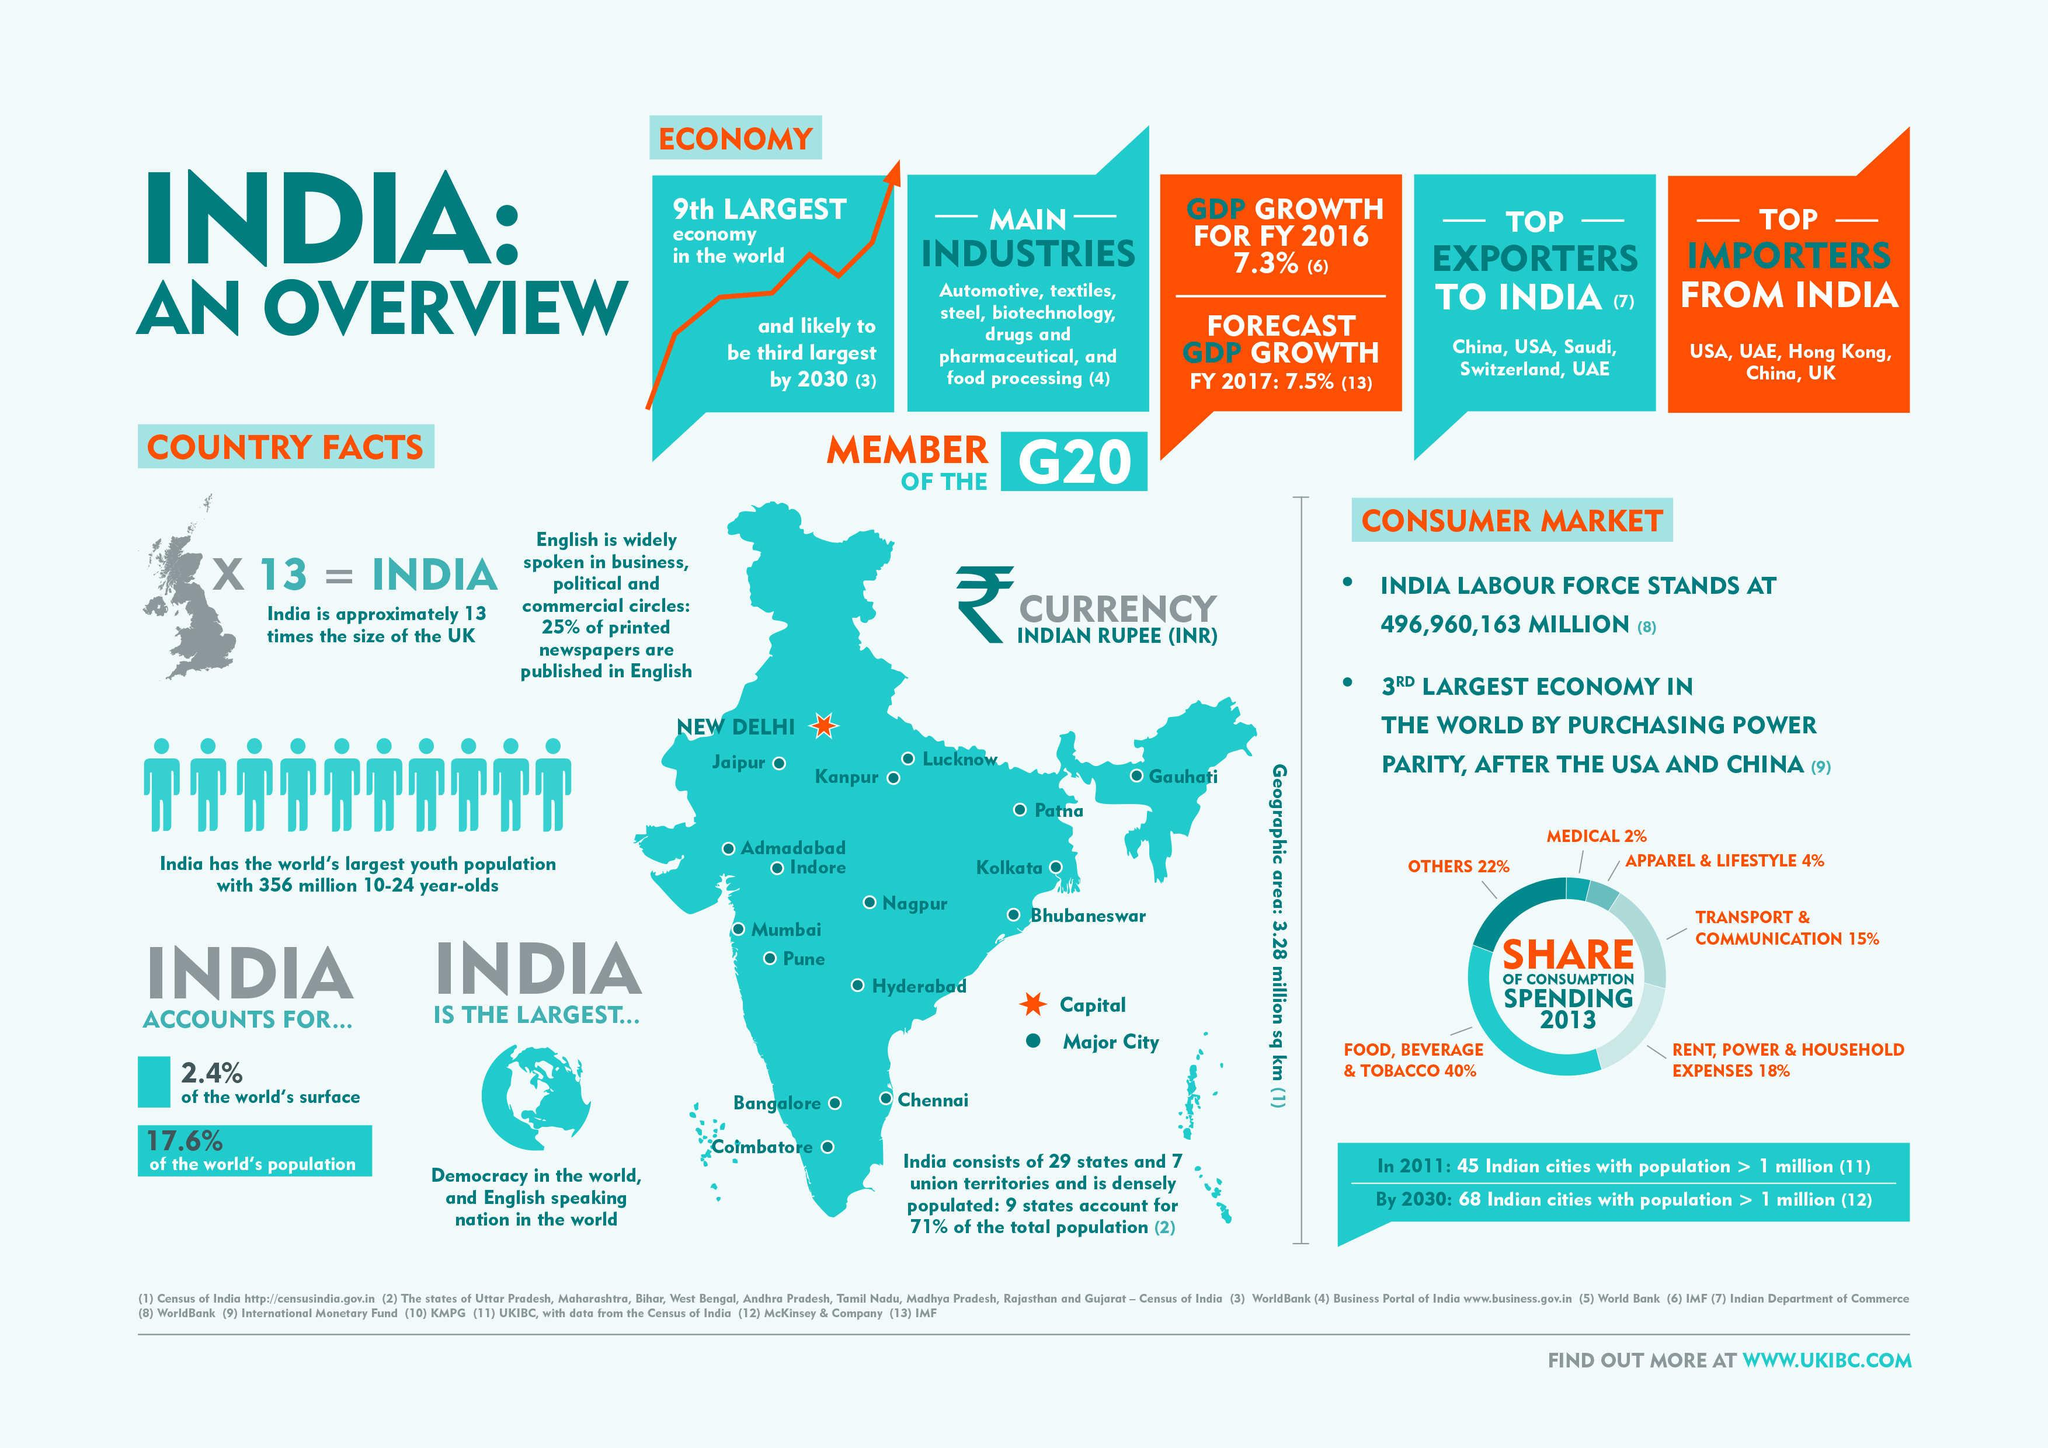Specify some key components in this picture. In 2013, transportation and communication industry accounted for 15% of total consumption spending in India, according to data sources. New Delhi is the capital city of India. In 2013, the percentage share of consumption spending in the medical industry in India was approximately 2%. 